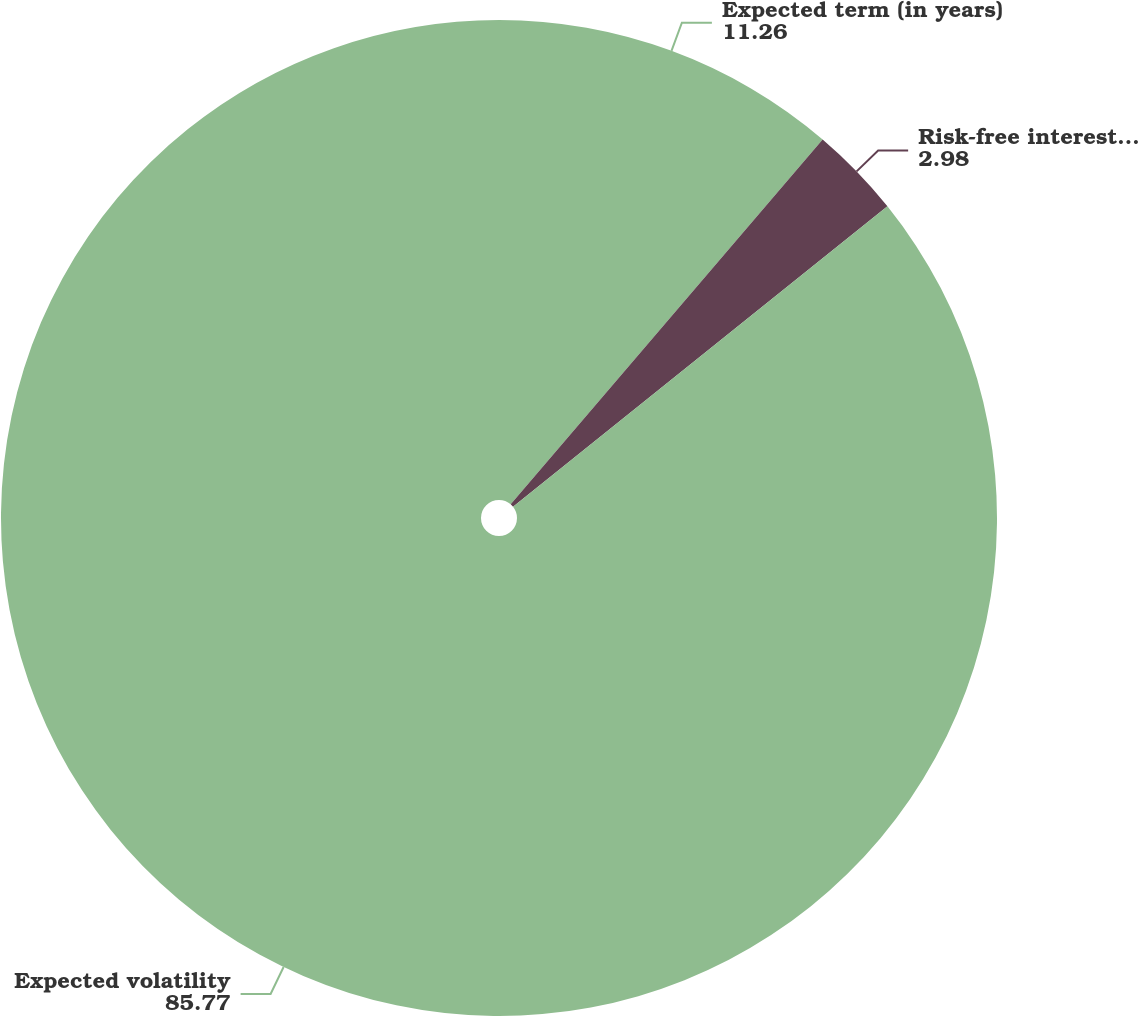Convert chart. <chart><loc_0><loc_0><loc_500><loc_500><pie_chart><fcel>Expected term (in years)<fcel>Risk-free interest rate<fcel>Expected volatility<nl><fcel>11.26%<fcel>2.98%<fcel>85.77%<nl></chart> 